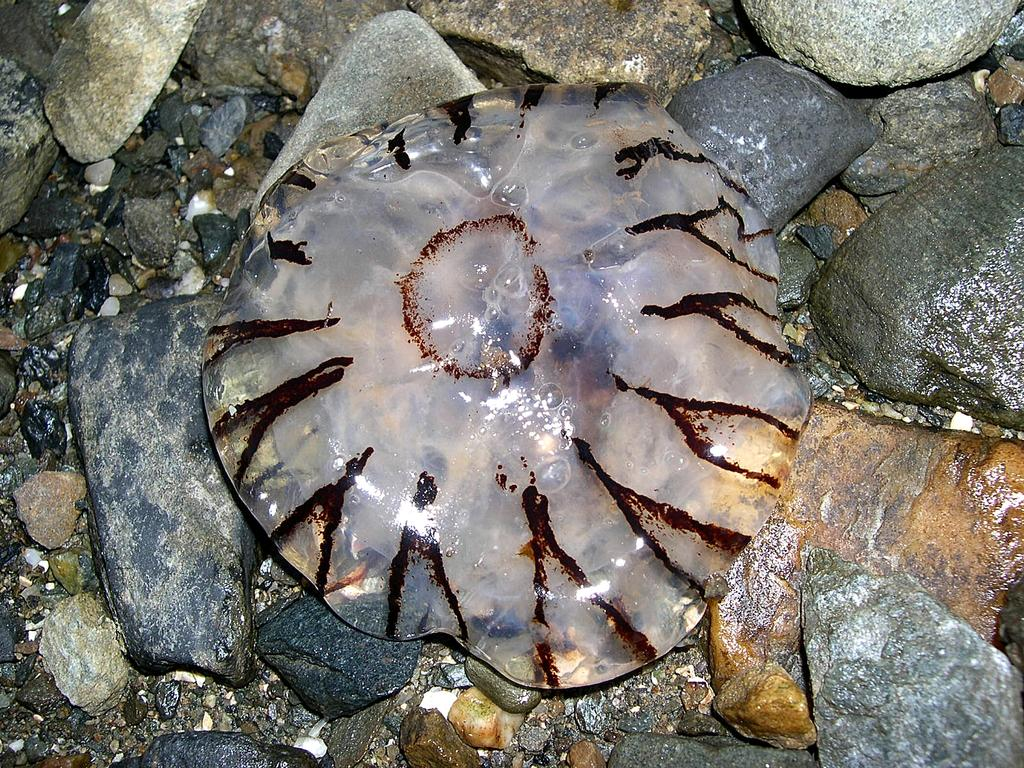What is the main object in the image? There is a plastic cover in the image. What is inside the plastic cover? There is liquid inside the plastic cover. What type of surface is visible in the image? The ground in the image has cobblestones. How many tomatoes can be seen growing on the property in the image? There are no tomatoes or property visible in the image; it only features a plastic cover with liquid and a cobblestone surface. 